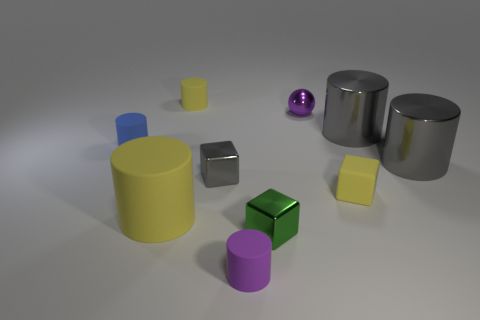How many large things are either green blocks or purple objects?
Keep it short and to the point. 0. There is a thing that is the same color as the tiny shiny ball; what is it made of?
Your answer should be very brief. Rubber. Is there a yellow object that has the same material as the small blue object?
Ensure brevity in your answer.  Yes. There is a purple object that is behind the purple rubber thing; is its size the same as the large yellow object?
Make the answer very short. No. Is there a large thing that is to the right of the small purple thing in front of the metallic cube in front of the gray block?
Your answer should be very brief. Yes. How many rubber objects are large balls or tiny yellow cylinders?
Your response must be concise. 1. How many other objects are there of the same shape as the green metal object?
Keep it short and to the point. 2. Is the number of gray blocks greater than the number of tiny green rubber spheres?
Provide a short and direct response. Yes. There is a yellow rubber cylinder that is in front of the cylinder that is behind the purple thing that is behind the gray cube; how big is it?
Give a very brief answer. Large. How big is the yellow matte object that is right of the tiny gray metal object?
Make the answer very short. Small. 